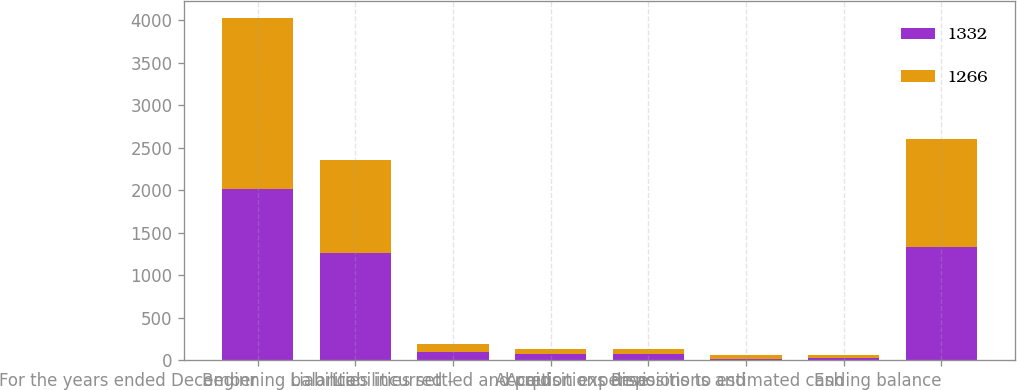<chart> <loc_0><loc_0><loc_500><loc_500><stacked_bar_chart><ecel><fcel>For the years ended December<fcel>Beginning balance<fcel>Liabilities incurred -<fcel>Liabilities settled and paid<fcel>Accretion expense<fcel>Acquisitions dispositions and<fcel>Revisions to estimated cash<fcel>Ending balance<nl><fcel>1332<fcel>2013<fcel>1266<fcel>101<fcel>72<fcel>68<fcel>10<fcel>21<fcel>1332<nl><fcel>1266<fcel>2012<fcel>1089<fcel>86<fcel>58<fcel>61<fcel>50<fcel>38<fcel>1266<nl></chart> 